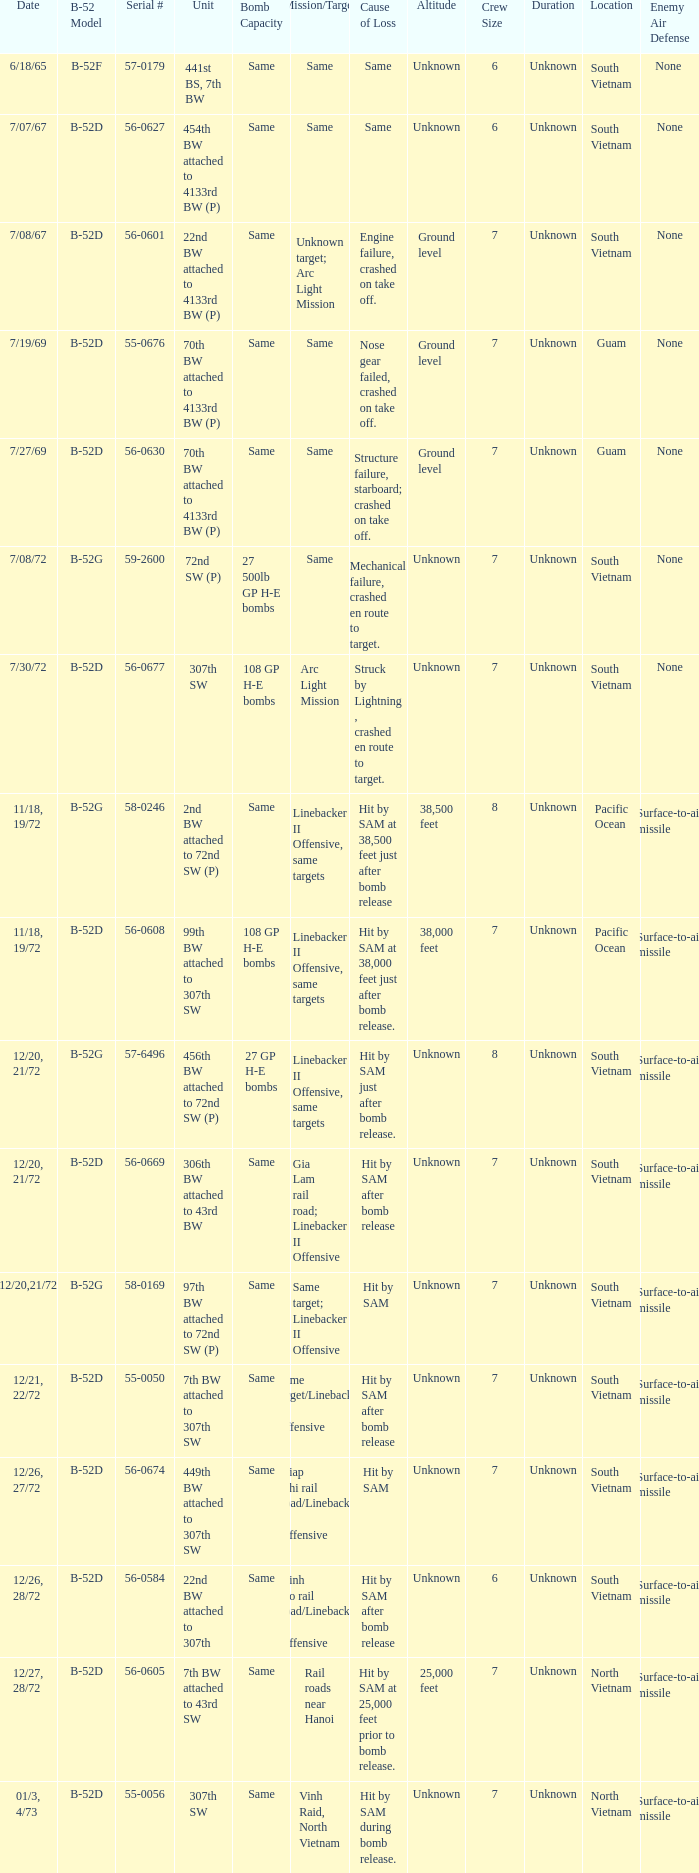When  27 gp h-e bombs the capacity of the bomb what is the cause of loss? Hit by SAM just after bomb release. 